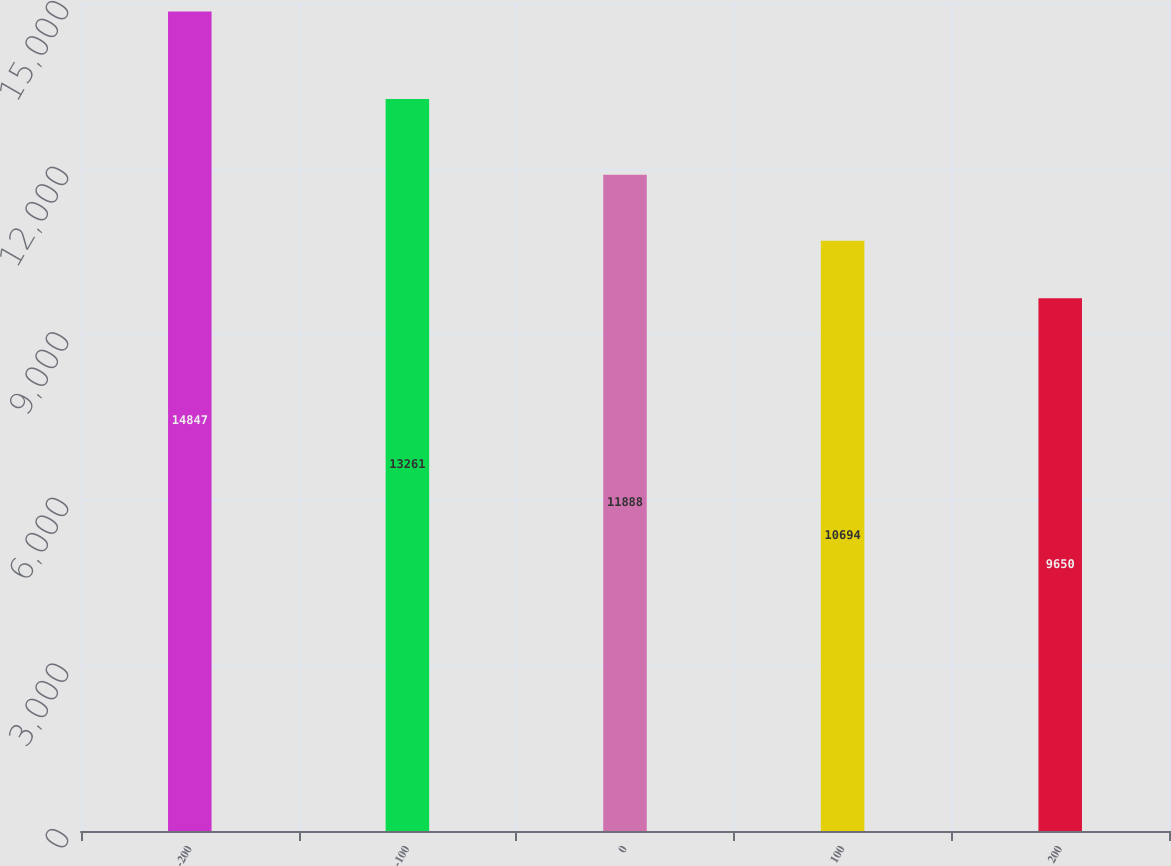Convert chart to OTSL. <chart><loc_0><loc_0><loc_500><loc_500><bar_chart><fcel>-200<fcel>-100<fcel>0<fcel>100<fcel>200<nl><fcel>14847<fcel>13261<fcel>11888<fcel>10694<fcel>9650<nl></chart> 